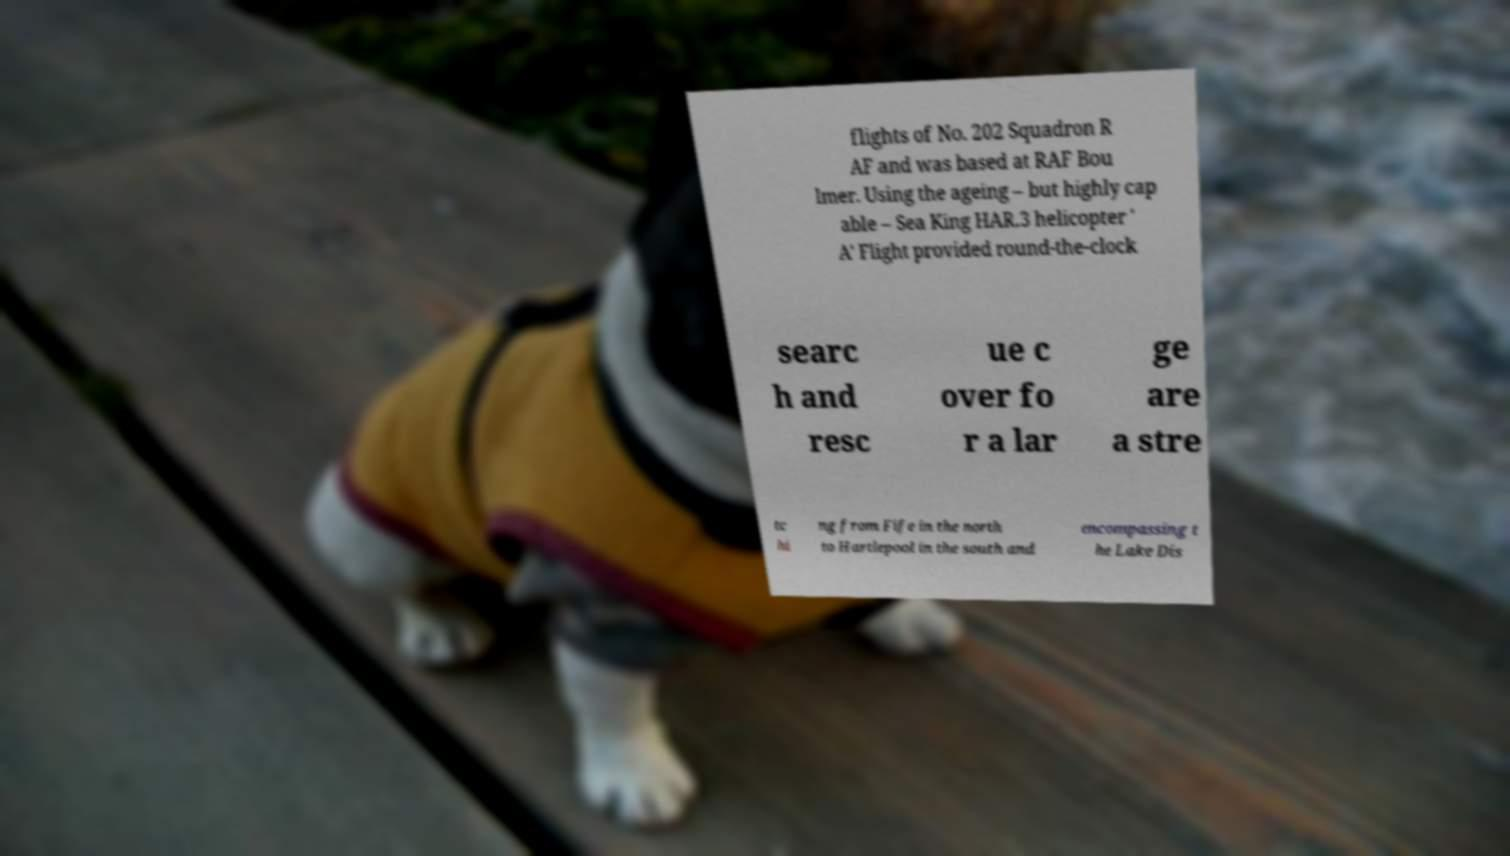There's text embedded in this image that I need extracted. Can you transcribe it verbatim? flights of No. 202 Squadron R AF and was based at RAF Bou lmer. Using the ageing – but highly cap able – Sea King HAR.3 helicopter ' A' Flight provided round-the-clock searc h and resc ue c over fo r a lar ge are a stre tc hi ng from Fife in the north to Hartlepool in the south and encompassing t he Lake Dis 